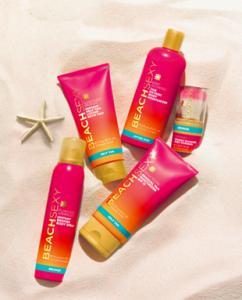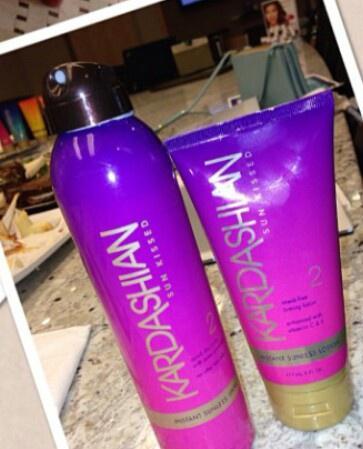The first image is the image on the left, the second image is the image on the right. Given the left and right images, does the statement "There are a total of 5 brightly colored self-tanning accessories laying in the sand." hold true? Answer yes or no. Yes. 